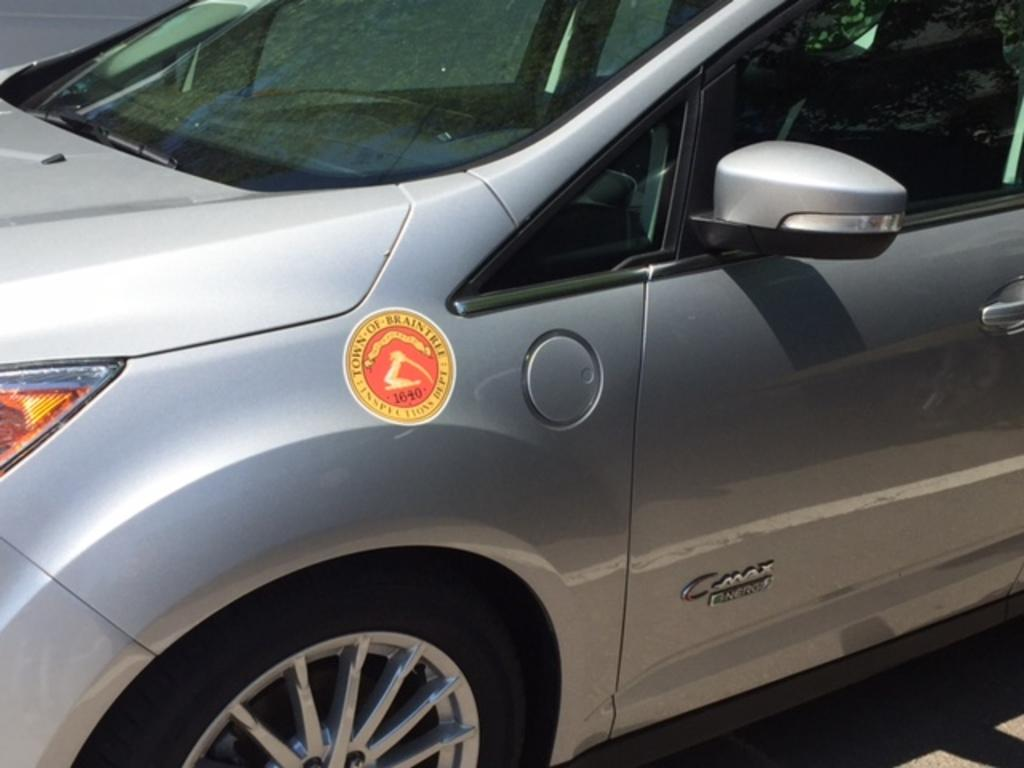What is the main subject of the picture? The main subject of the picture is a car. Can you describe any specific features on the left side of the car? Yes, there is a side light and a sticker on the left side of the car. What is present on the right side of the car? On the right side of the car, there is a mirror, a seat, a window, a door, and a wheel. What type of wound can be seen on the car in the image? There is no wound present on the car in the image. Can you tell me how many coaches are visible in the image? There are no coaches present in the image; it features a car. 